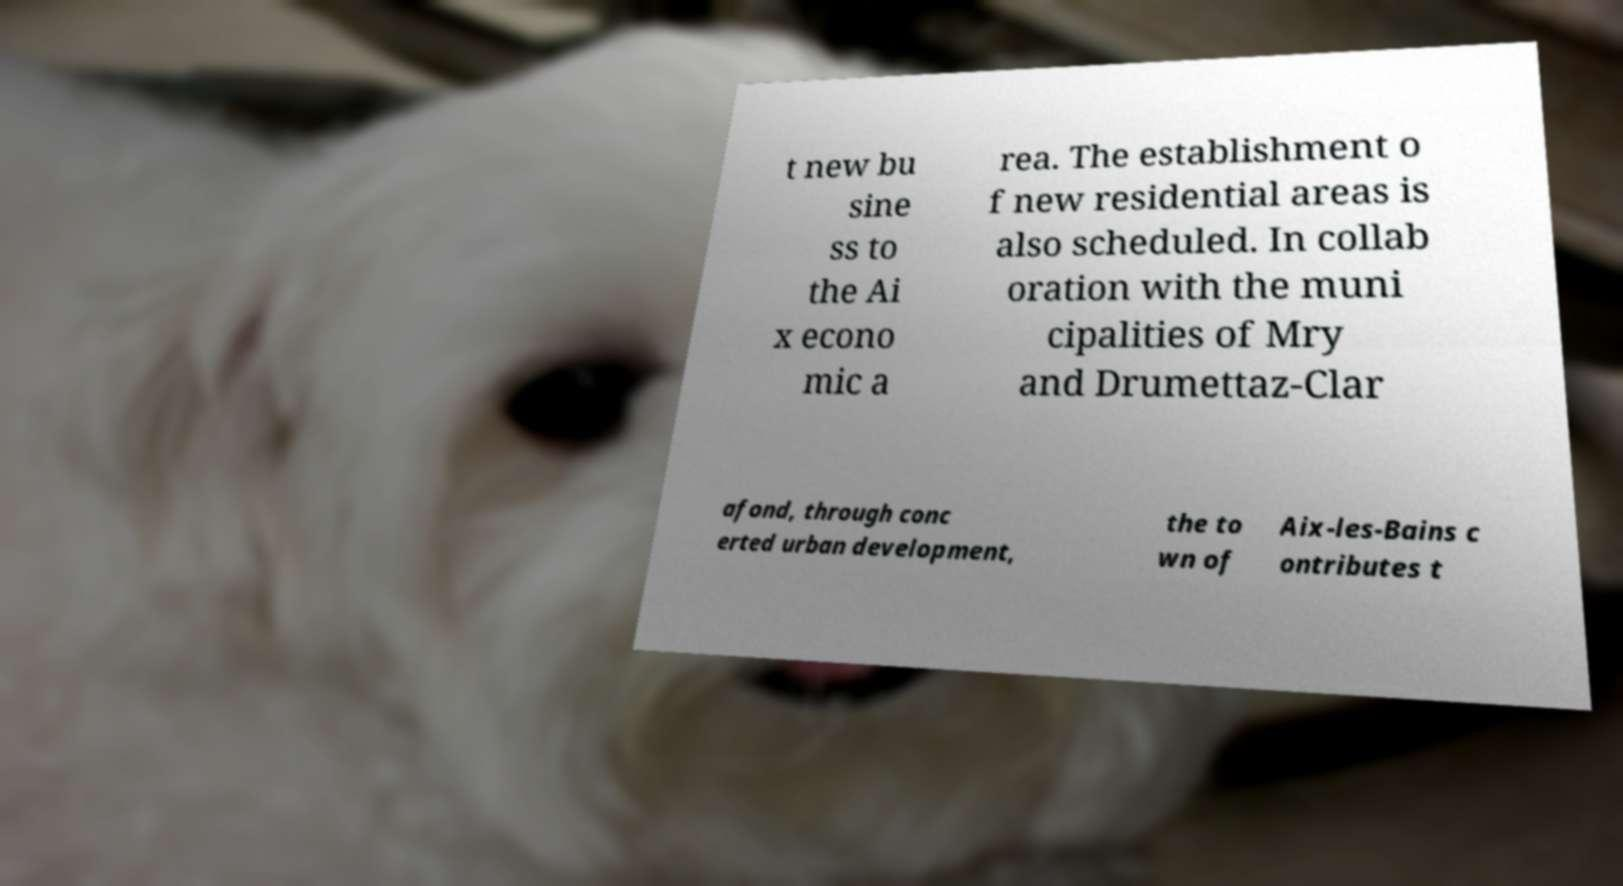For documentation purposes, I need the text within this image transcribed. Could you provide that? t new bu sine ss to the Ai x econo mic a rea. The establishment o f new residential areas is also scheduled. In collab oration with the muni cipalities of Mry and Drumettaz-Clar afond, through conc erted urban development, the to wn of Aix-les-Bains c ontributes t 